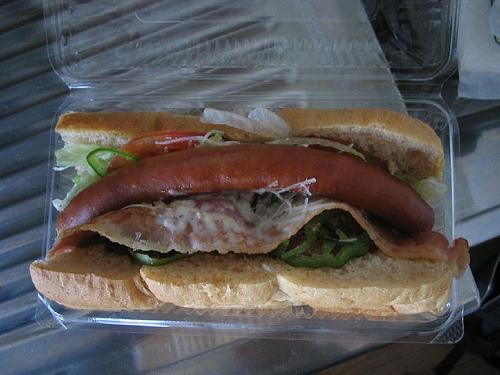What sort of container holds the sandwich?
Quick response, please. Plastic. Is there lettuce in the sandwich?
Give a very brief answer. Yes. What is on top of the sandwich?
Give a very brief answer. Sausage. 